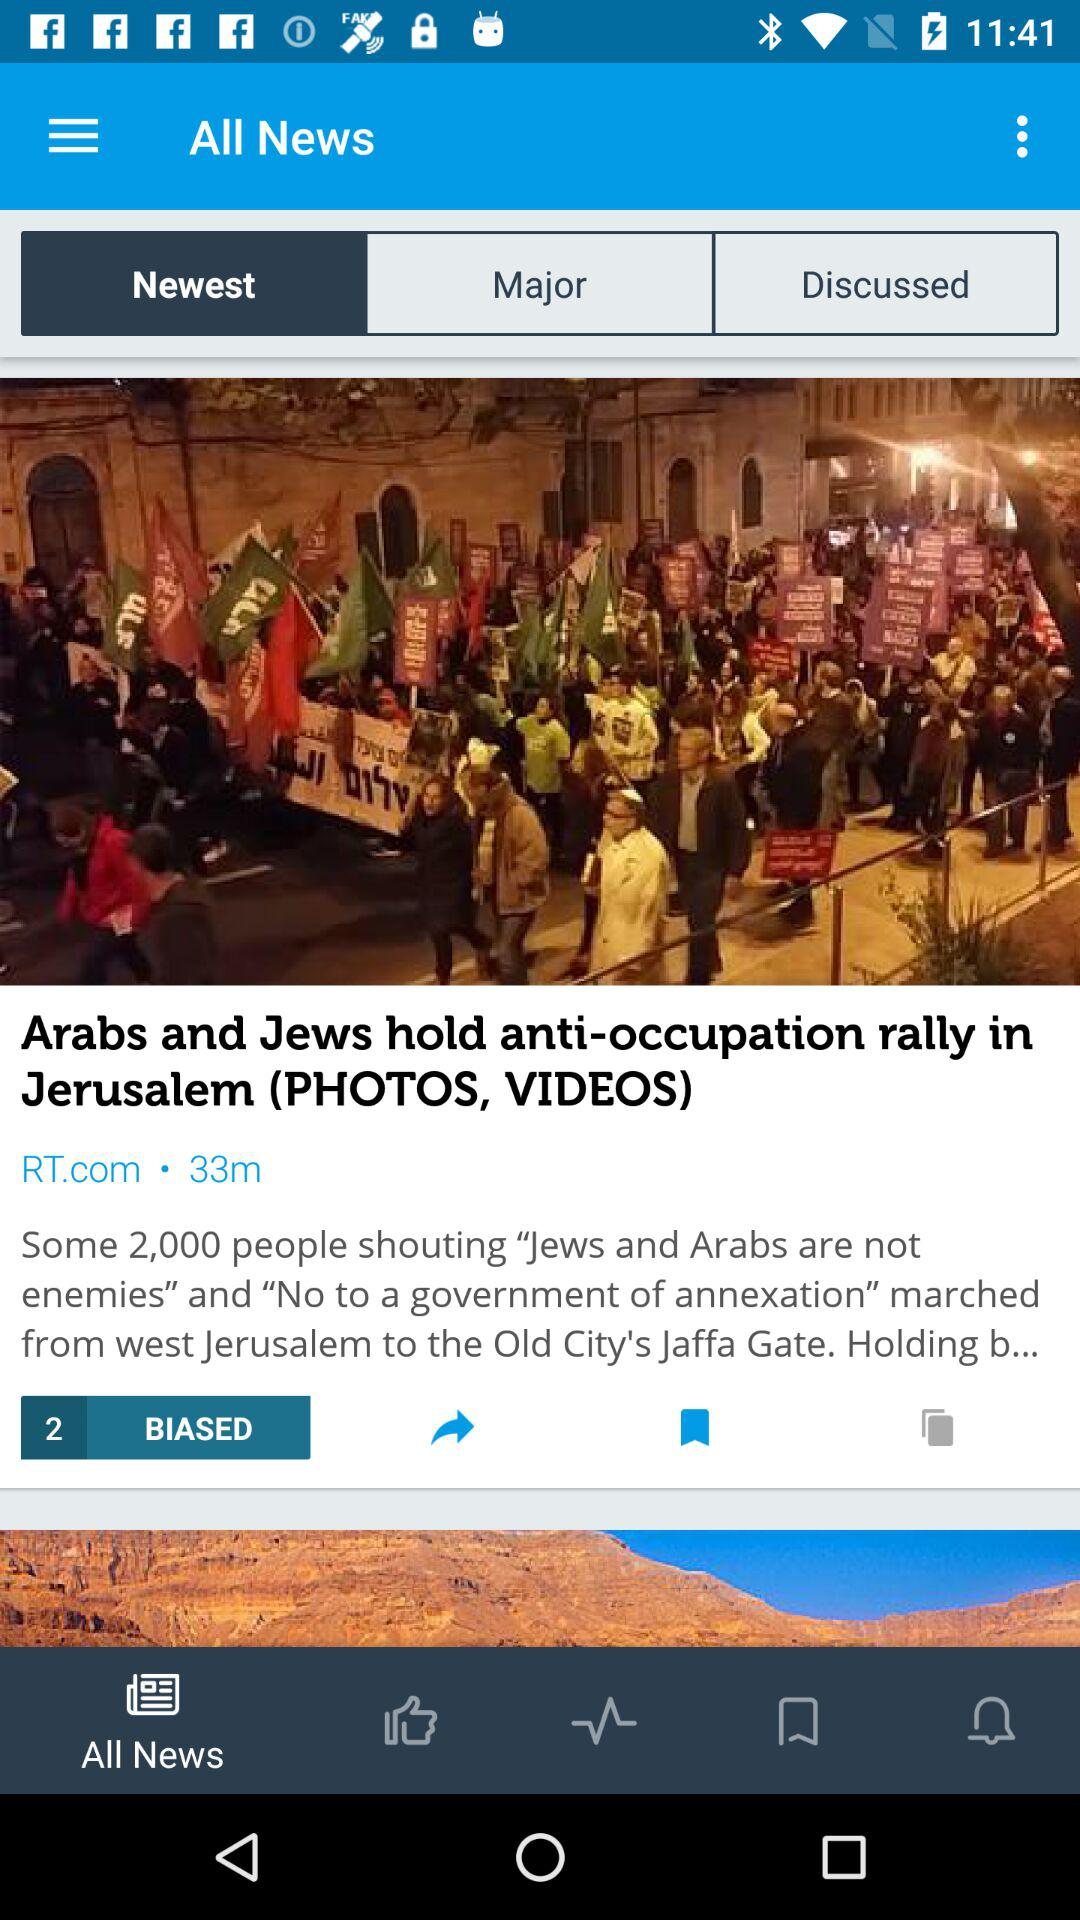How many people were shouting in the march that went from west Jerusalem to the old city's Jaffa gate? There are some 2,000 people. 